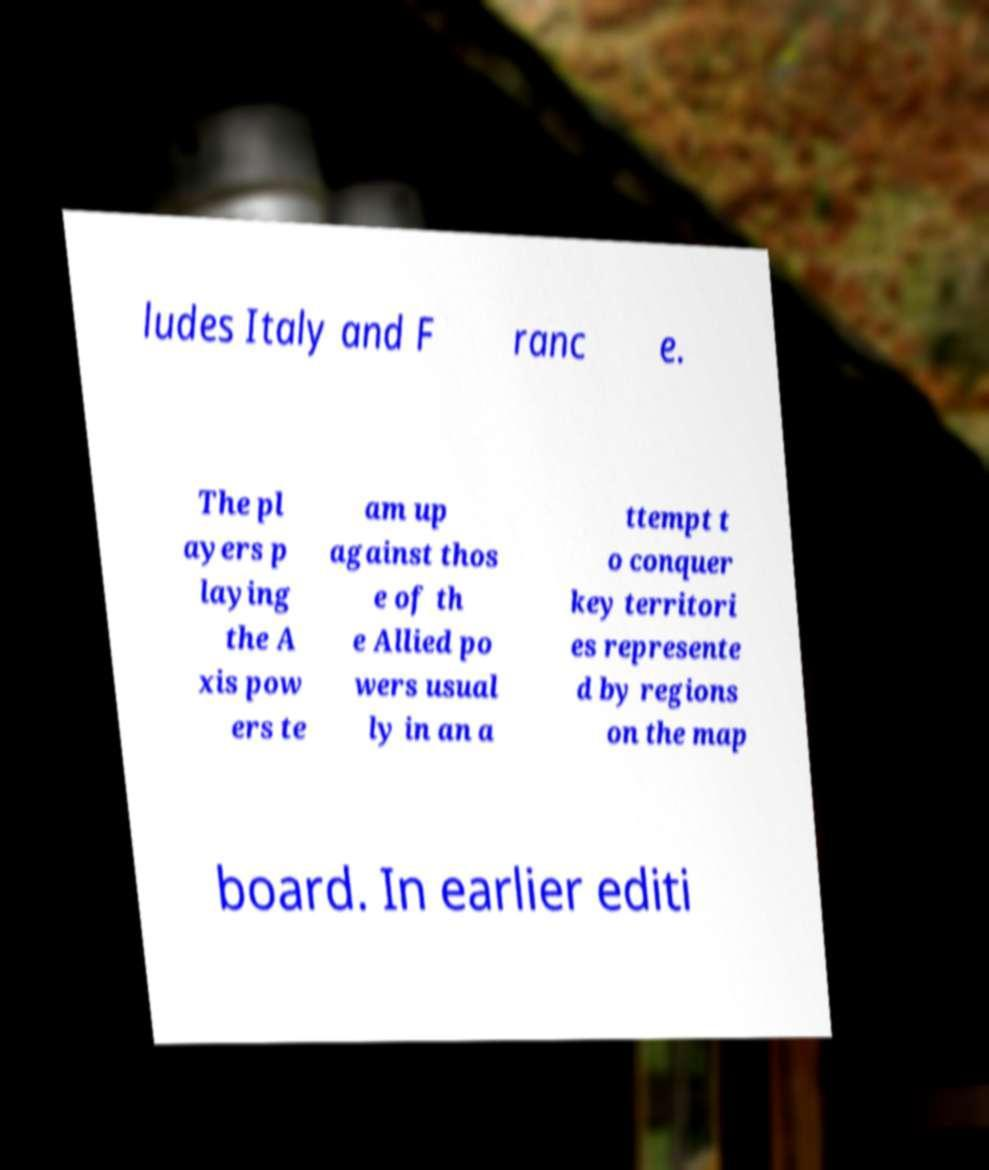Could you extract and type out the text from this image? ludes Italy and F ranc e. The pl ayers p laying the A xis pow ers te am up against thos e of th e Allied po wers usual ly in an a ttempt t o conquer key territori es represente d by regions on the map board. In earlier editi 